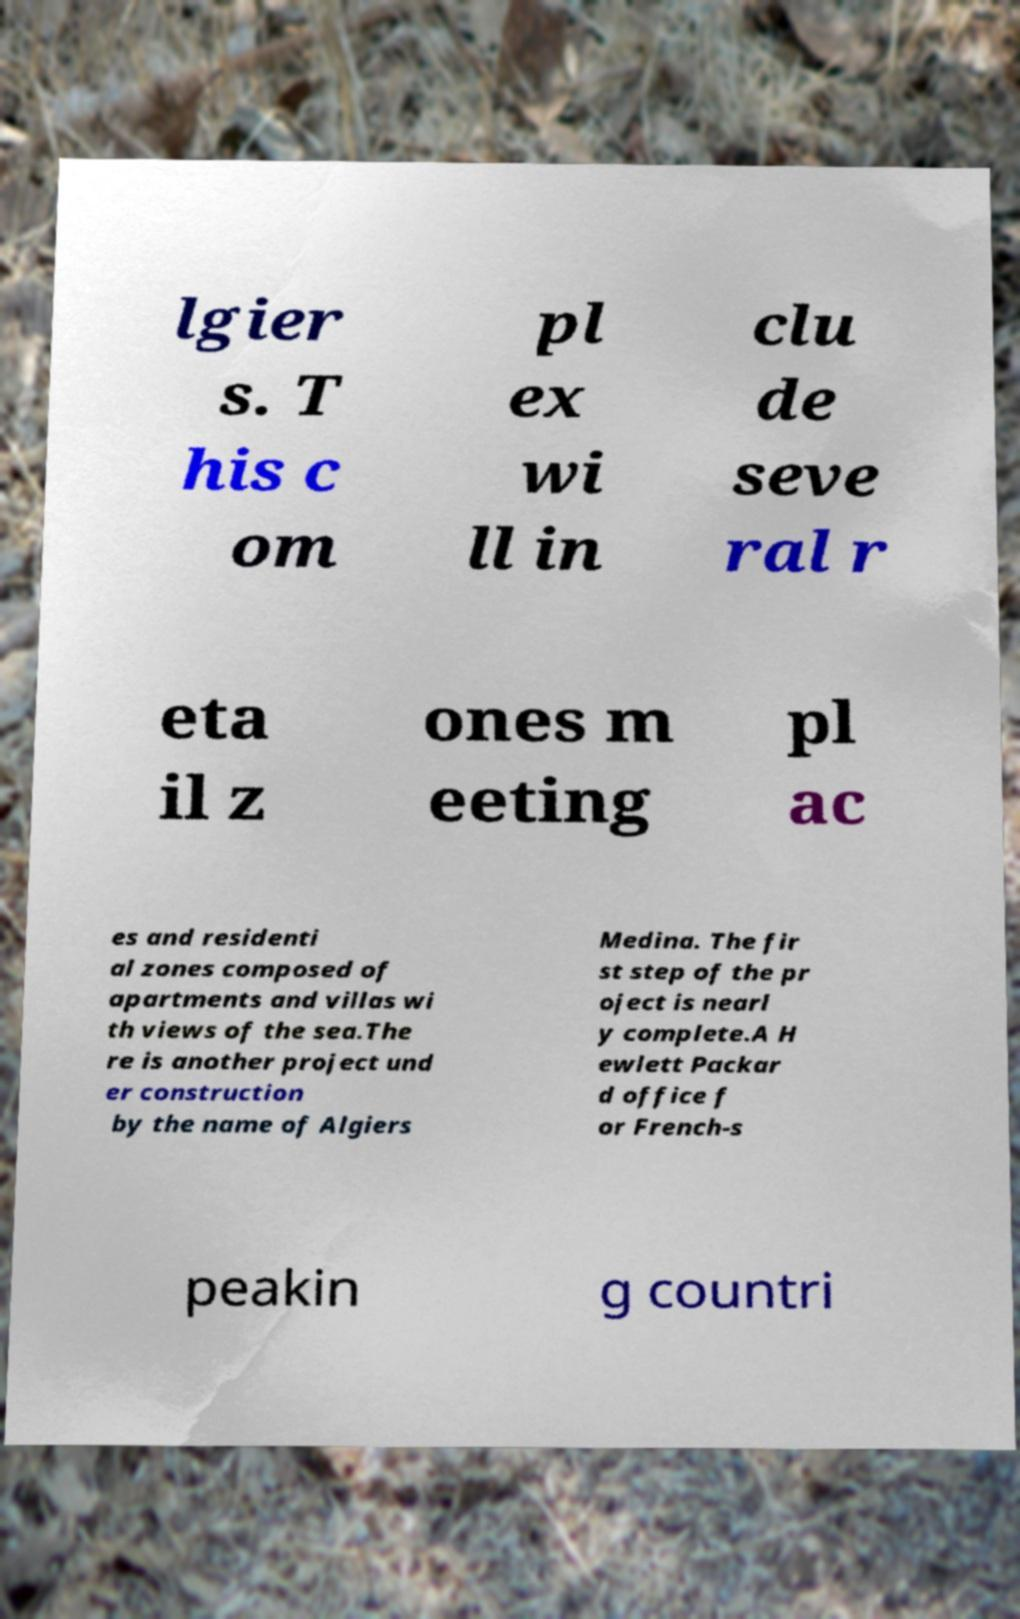For documentation purposes, I need the text within this image transcribed. Could you provide that? lgier s. T his c om pl ex wi ll in clu de seve ral r eta il z ones m eeting pl ac es and residenti al zones composed of apartments and villas wi th views of the sea.The re is another project und er construction by the name of Algiers Medina. The fir st step of the pr oject is nearl y complete.A H ewlett Packar d office f or French-s peakin g countri 